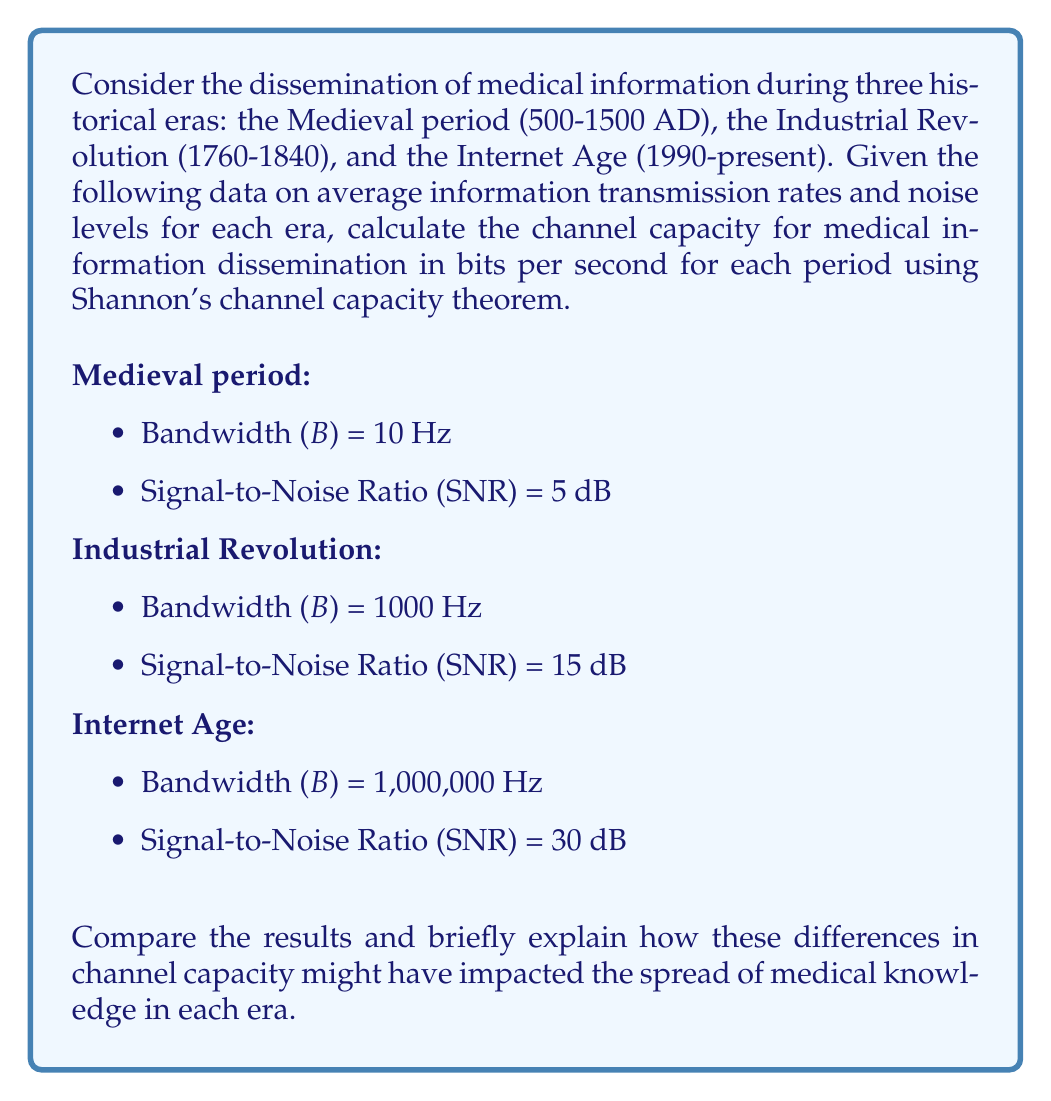Could you help me with this problem? To solve this problem, we'll use Shannon's channel capacity theorem, which states that the channel capacity (C) in bits per second is given by:

$$ C = B \log_2(1 + SNR) $$

Where:
B = Bandwidth in Hz
SNR = Signal-to-Noise Ratio

However, the SNR values given are in decibels (dB), so we need to convert them to linear scale first using the formula:

$$ SNR_{linear} = 10^{SNR_{dB}/10} $$

Let's calculate the channel capacity for each era:

1. Medieval period (500-1500 AD):
   $SNR_{linear} = 10^{5/10} \approx 3.16228$
   $C_{medieval} = 10 \log_2(1 + 3.16228) \approx 21.9358$ bits/second

2. Industrial Revolution (1760-1840):
   $SNR_{linear} = 10^{15/10} \approx 31.6228$
   $C_{industrial} = 1000 \log_2(1 + 31.6228) \approx 4981.4426$ bits/second

3. Internet Age (1990-present):
   $SNR_{linear} = 10^{30/10} = 1000$
   $C_{internet} = 1,000,000 \log_2(1 + 1000) \approx 9,965,784.2843$ bits/second

The significant differences in channel capacity between these eras reflect the dramatic improvements in information dissemination technology over time. In the Medieval period, the low channel capacity (about 22 bits/second) indicates that medical information spread slowly, mainly through oral tradition and handwritten manuscripts. This limited the availability and accuracy of medical knowledge.

During the Industrial Revolution, the channel capacity increased to about 4,981 bits/second, representing the impact of the printing press and improved transportation systems. This allowed for wider distribution of medical texts and faster spread of new medical discoveries, contributing to advancements in public health and medical practice.

In the Internet Age, the channel capacity has increased enormously to nearly 10 million bits/second. This reflects the revolutionary impact of digital communication technologies, allowing for near-instantaneous global sharing of medical information. This has dramatically accelerated the dissemination of medical research, facilitated telemedicine, and improved access to health information for both professionals and the general public.
Answer: Channel capacities:
Medieval period: 21.9358 bits/second
Industrial Revolution: 4,981.4426 bits/second
Internet Age: 9,965,784.2843 bits/second 